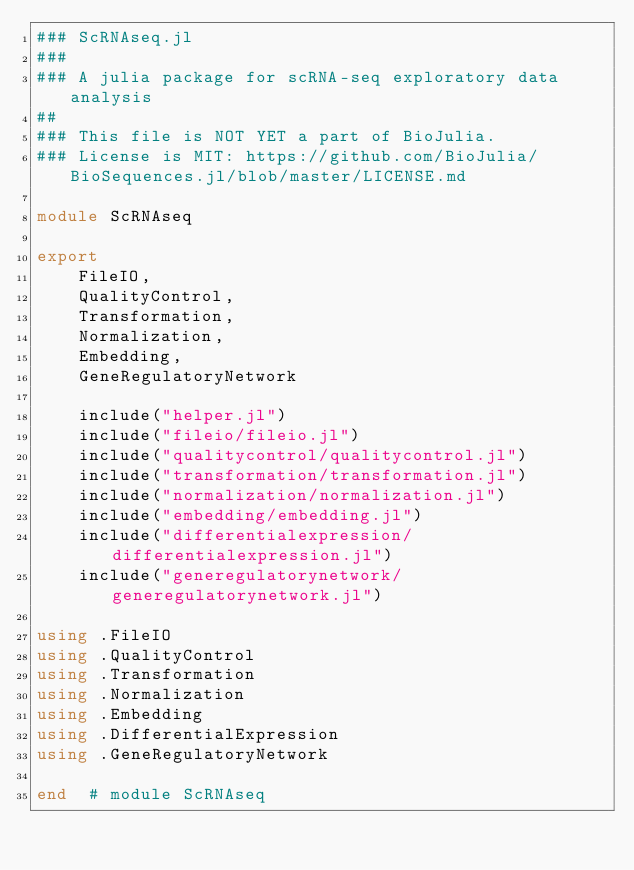<code> <loc_0><loc_0><loc_500><loc_500><_Julia_>### ScRNAseq.jl
###
### A julia package for scRNA-seq exploratory data analysis
##
### This file is NOT YET a part of BioJulia.
### License is MIT: https://github.com/BioJulia/BioSequences.jl/blob/master/LICENSE.md

module ScRNAseq

export
    FileIO,
    QualityControl,
    Transformation,
    Normalization,
    Embedding,
    GeneRegulatoryNetwork

    include("helper.jl")
    include("fileio/fileio.jl")
    include("qualitycontrol/qualitycontrol.jl")
    include("transformation/transformation.jl")
    include("normalization/normalization.jl")
    include("embedding/embedding.jl")
    include("differentialexpression/differentialexpression.jl")
    include("generegulatorynetwork/generegulatorynetwork.jl")

using .FileIO
using .QualityControl
using .Transformation
using .Normalization
using .Embedding
using .DifferentialExpression
using .GeneRegulatoryNetwork

end  # module ScRNAseq</code> 